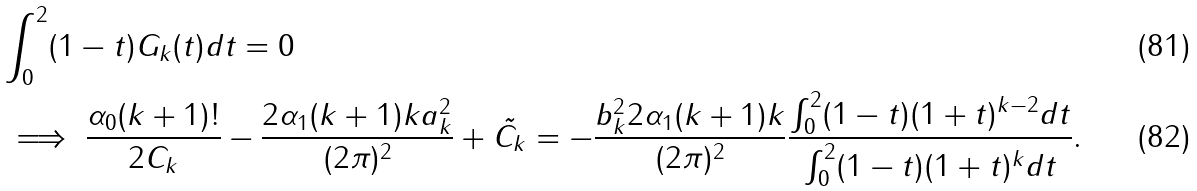<formula> <loc_0><loc_0><loc_500><loc_500>& \int _ { 0 } ^ { 2 } ( 1 - t ) G _ { k } ( t ) d t = 0 \\ & \implies \frac { \alpha _ { 0 } ( k + 1 ) ! } { 2 C _ { k } } - \frac { 2 \alpha _ { 1 } ( k + 1 ) k a _ { k } ^ { 2 } } { ( 2 \pi ) ^ { 2 } } + \tilde { C _ { k } } = - \frac { b _ { k } ^ { 2 } 2 \alpha _ { 1 } ( k + 1 ) k } { ( 2 \pi ) ^ { 2 } } \frac { \int _ { 0 } ^ { 2 } ( 1 - t ) ( 1 + t ) ^ { k - 2 } d t } { \int _ { 0 } ^ { 2 } ( 1 - t ) ( 1 + t ) ^ { k } d t } .</formula> 